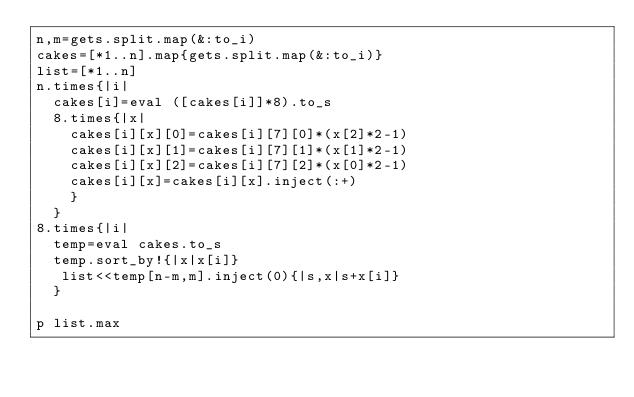<code> <loc_0><loc_0><loc_500><loc_500><_Ruby_>n,m=gets.split.map(&:to_i)
cakes=[*1..n].map{gets.split.map(&:to_i)}
list=[*1..n]
n.times{|i|
  cakes[i]=eval ([cakes[i]]*8).to_s
  8.times{|x|
    cakes[i][x][0]=cakes[i][7][0]*(x[2]*2-1)
    cakes[i][x][1]=cakes[i][7][1]*(x[1]*2-1)
    cakes[i][x][2]=cakes[i][7][2]*(x[0]*2-1)
    cakes[i][x]=cakes[i][x].inject(:+)
    }
  }
8.times{|i|
  temp=eval cakes.to_s
  temp.sort_by!{|x|x[i]}
   list<<temp[n-m,m].inject(0){|s,x|s+x[i]}
  }
  
p list.max</code> 